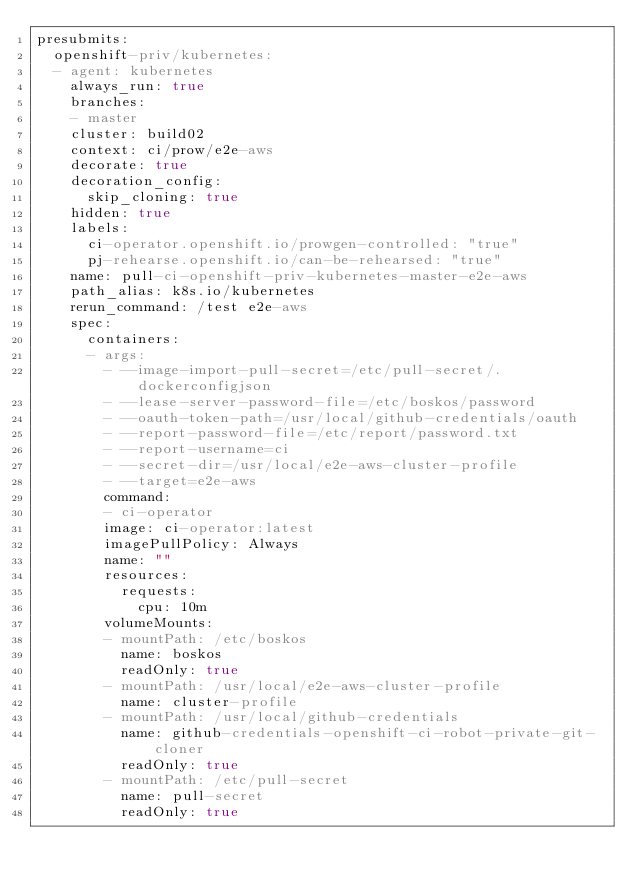<code> <loc_0><loc_0><loc_500><loc_500><_YAML_>presubmits:
  openshift-priv/kubernetes:
  - agent: kubernetes
    always_run: true
    branches:
    - master
    cluster: build02
    context: ci/prow/e2e-aws
    decorate: true
    decoration_config:
      skip_cloning: true
    hidden: true
    labels:
      ci-operator.openshift.io/prowgen-controlled: "true"
      pj-rehearse.openshift.io/can-be-rehearsed: "true"
    name: pull-ci-openshift-priv-kubernetes-master-e2e-aws
    path_alias: k8s.io/kubernetes
    rerun_command: /test e2e-aws
    spec:
      containers:
      - args:
        - --image-import-pull-secret=/etc/pull-secret/.dockerconfigjson
        - --lease-server-password-file=/etc/boskos/password
        - --oauth-token-path=/usr/local/github-credentials/oauth
        - --report-password-file=/etc/report/password.txt
        - --report-username=ci
        - --secret-dir=/usr/local/e2e-aws-cluster-profile
        - --target=e2e-aws
        command:
        - ci-operator
        image: ci-operator:latest
        imagePullPolicy: Always
        name: ""
        resources:
          requests:
            cpu: 10m
        volumeMounts:
        - mountPath: /etc/boskos
          name: boskos
          readOnly: true
        - mountPath: /usr/local/e2e-aws-cluster-profile
          name: cluster-profile
        - mountPath: /usr/local/github-credentials
          name: github-credentials-openshift-ci-robot-private-git-cloner
          readOnly: true
        - mountPath: /etc/pull-secret
          name: pull-secret
          readOnly: true</code> 